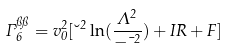Convert formula to latex. <formula><loc_0><loc_0><loc_500><loc_500>\Gamma _ { 6 } ^ { \pi \pi } = v _ { 0 } ^ { 2 } [ \lambda ^ { 2 } \ln ( \frac { \Lambda ^ { 2 } } { - \mu ^ { 2 } } ) + I R + F ]</formula> 